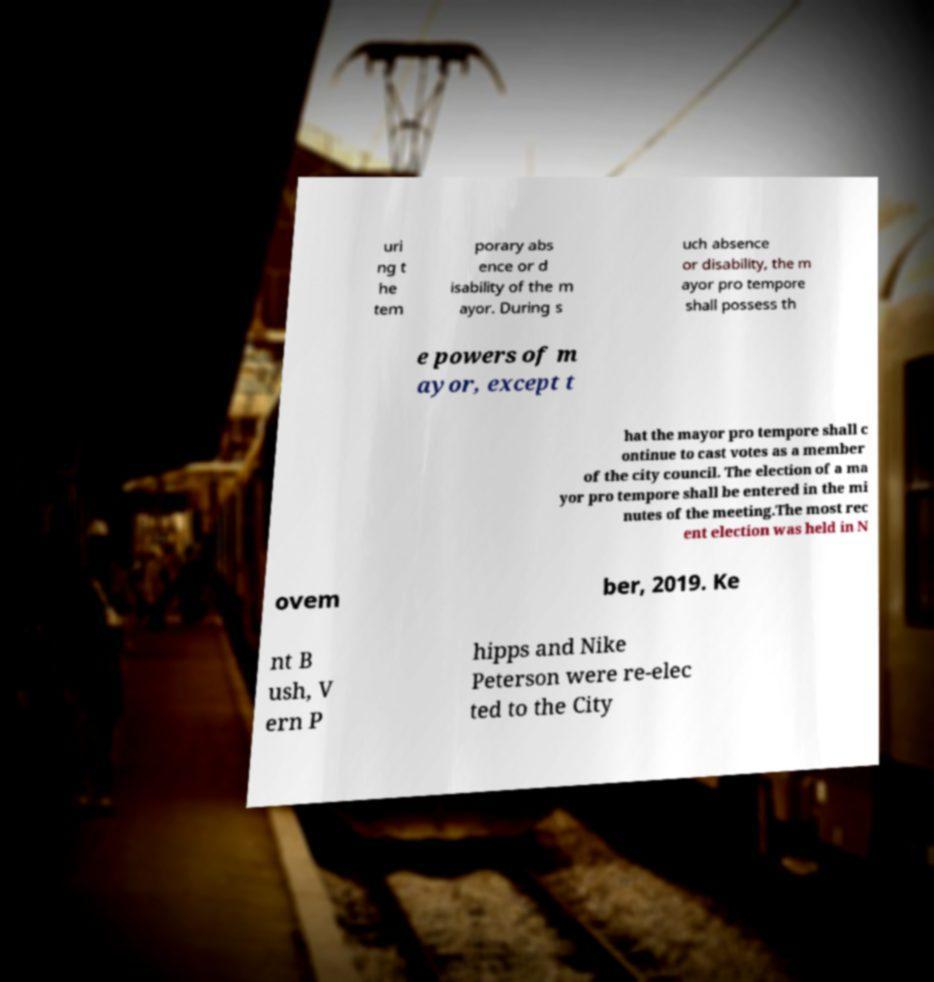Could you extract and type out the text from this image? uri ng t he tem porary abs ence or d isability of the m ayor. During s uch absence or disability, the m ayor pro tempore shall possess th e powers of m ayor, except t hat the mayor pro tempore shall c ontinue to cast votes as a member of the city council. The election of a ma yor pro tempore shall be entered in the mi nutes of the meeting.The most rec ent election was held in N ovem ber, 2019. Ke nt B ush, V ern P hipps and Nike Peterson were re-elec ted to the City 